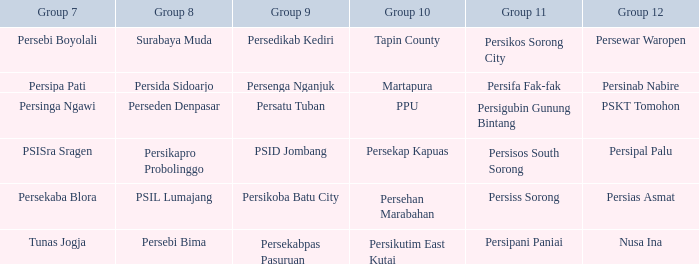When  persikos sorong city played in group 11, who played in group 7? Persebi Boyolali. 